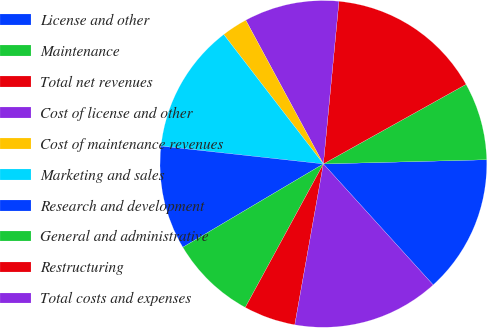Convert chart. <chart><loc_0><loc_0><loc_500><loc_500><pie_chart><fcel>License and other<fcel>Maintenance<fcel>Total net revenues<fcel>Cost of license and other<fcel>Cost of maintenance revenues<fcel>Marketing and sales<fcel>Research and development<fcel>General and administrative<fcel>Restructuring<fcel>Total costs and expenses<nl><fcel>13.68%<fcel>7.69%<fcel>15.38%<fcel>9.4%<fcel>2.56%<fcel>12.82%<fcel>10.26%<fcel>8.55%<fcel>5.13%<fcel>14.53%<nl></chart> 